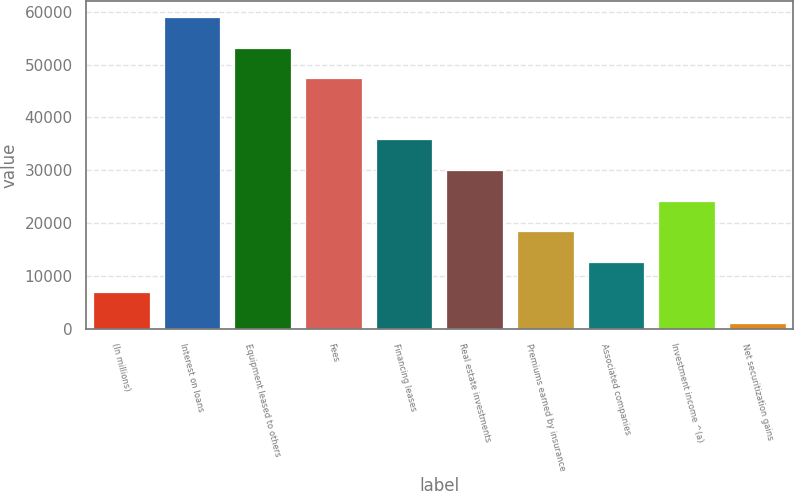Convert chart. <chart><loc_0><loc_0><loc_500><loc_500><bar_chart><fcel>(In millions)<fcel>Interest on loans<fcel>Equipment leased to others<fcel>Fees<fcel>Financing leases<fcel>Real estate investments<fcel>Premiums earned by insurance<fcel>Associated companies<fcel>Investment income ^(a)<fcel>Net securitization gains<nl><fcel>6965<fcel>58967<fcel>53189<fcel>47411<fcel>35855<fcel>30077<fcel>18521<fcel>12743<fcel>24299<fcel>1187<nl></chart> 